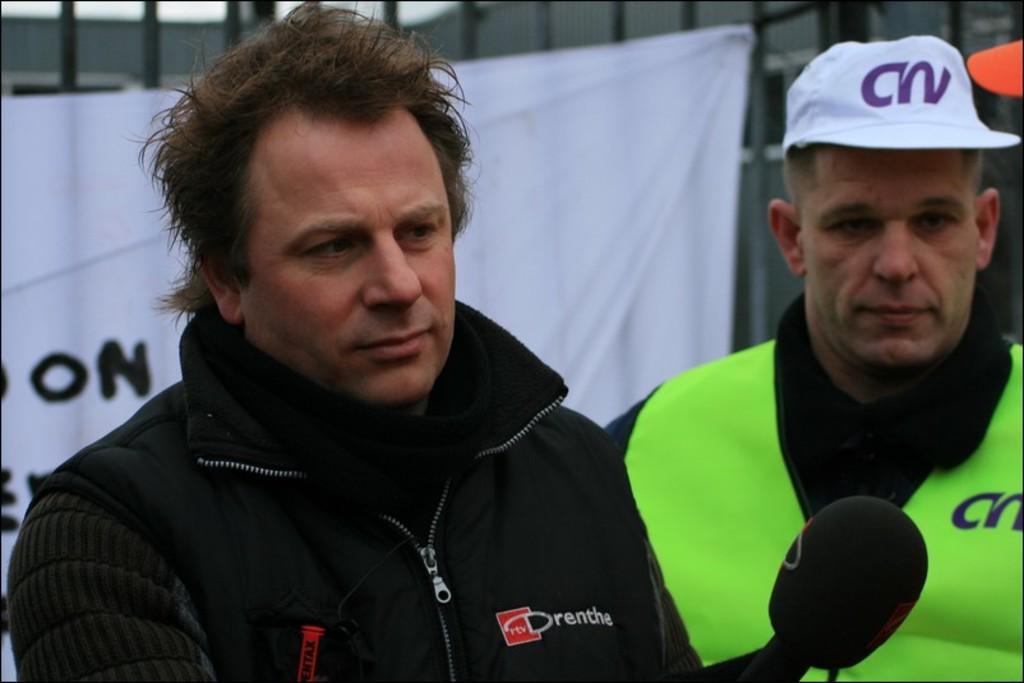How would you summarize this image in a sentence or two? In this image I can see on the left side a man is holding the microphone, he wore black color coat, on the right side there is another man. He wore green color coat, white color cap, behind them there is the white color cloth to an iron grill. 